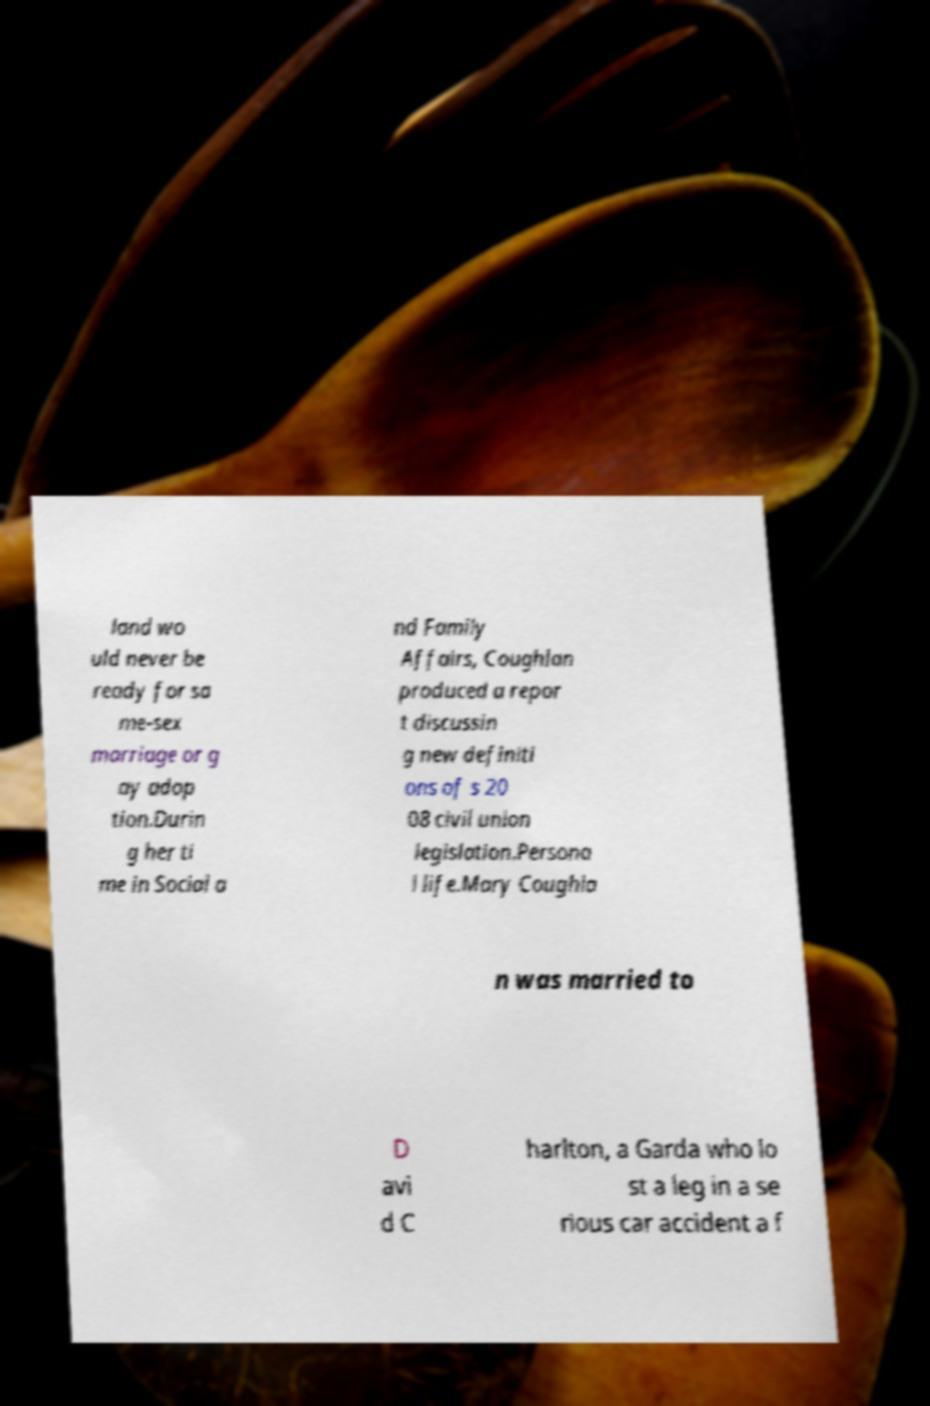Could you extract and type out the text from this image? land wo uld never be ready for sa me-sex marriage or g ay adop tion.Durin g her ti me in Social a nd Family Affairs, Coughlan produced a repor t discussin g new definiti ons of s 20 08 civil union legislation.Persona l life.Mary Coughla n was married to D avi d C harlton, a Garda who lo st a leg in a se rious car accident a f 